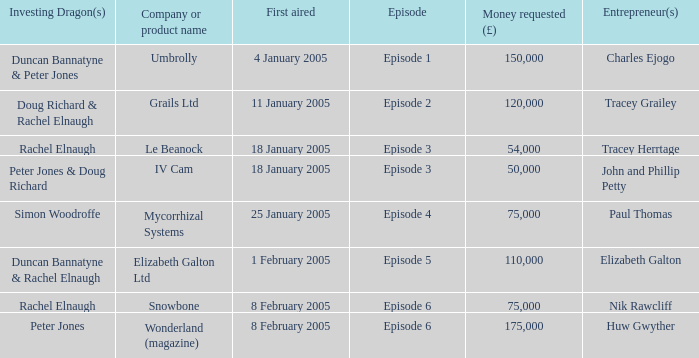What is the average money requested in the episode first aired on 18 January 2005 by the company/product name IV Cam 50000.0. I'm looking to parse the entire table for insights. Could you assist me with that? {'header': ['Investing Dragon(s)', 'Company or product name', 'First aired', 'Episode', 'Money requested (£)', 'Entrepreneur(s)'], 'rows': [['Duncan Bannatyne & Peter Jones', 'Umbrolly', '4 January 2005', 'Episode 1', '150,000', 'Charles Ejogo'], ['Doug Richard & Rachel Elnaugh', 'Grails Ltd', '11 January 2005', 'Episode 2', '120,000', 'Tracey Grailey'], ['Rachel Elnaugh', 'Le Beanock', '18 January 2005', 'Episode 3', '54,000', 'Tracey Herrtage'], ['Peter Jones & Doug Richard', 'IV Cam', '18 January 2005', 'Episode 3', '50,000', 'John and Phillip Petty'], ['Simon Woodroffe', 'Mycorrhizal Systems', '25 January 2005', 'Episode 4', '75,000', 'Paul Thomas'], ['Duncan Bannatyne & Rachel Elnaugh', 'Elizabeth Galton Ltd', '1 February 2005', 'Episode 5', '110,000', 'Elizabeth Galton'], ['Rachel Elnaugh', 'Snowbone', '8 February 2005', 'Episode 6', '75,000', 'Nik Rawcliff'], ['Peter Jones', 'Wonderland (magazine)', '8 February 2005', 'Episode 6', '175,000', 'Huw Gwyther']]} 